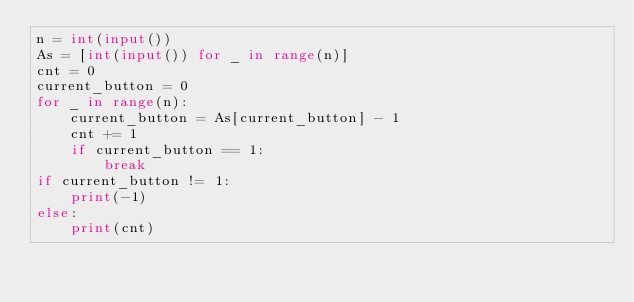<code> <loc_0><loc_0><loc_500><loc_500><_Python_>n = int(input())
As = [int(input()) for _ in range(n)]
cnt = 0
current_button = 0
for _ in range(n):
    current_button = As[current_button] - 1
    cnt += 1
    if current_button == 1:
        break
if current_button != 1:
    print(-1)
else:
    print(cnt)


</code> 